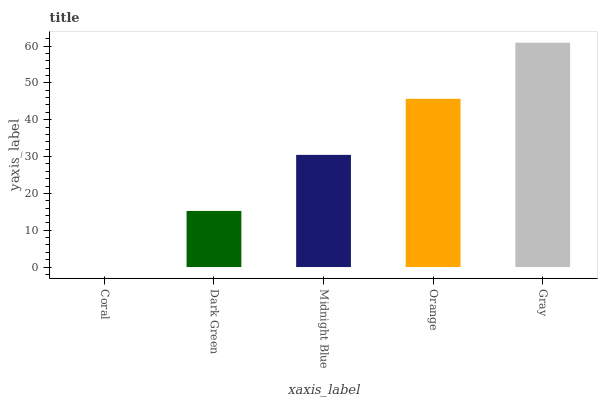Is Coral the minimum?
Answer yes or no. Yes. Is Gray the maximum?
Answer yes or no. Yes. Is Dark Green the minimum?
Answer yes or no. No. Is Dark Green the maximum?
Answer yes or no. No. Is Dark Green greater than Coral?
Answer yes or no. Yes. Is Coral less than Dark Green?
Answer yes or no. Yes. Is Coral greater than Dark Green?
Answer yes or no. No. Is Dark Green less than Coral?
Answer yes or no. No. Is Midnight Blue the high median?
Answer yes or no. Yes. Is Midnight Blue the low median?
Answer yes or no. Yes. Is Orange the high median?
Answer yes or no. No. Is Gray the low median?
Answer yes or no. No. 